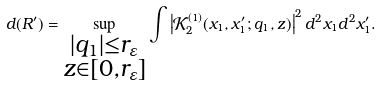Convert formula to latex. <formula><loc_0><loc_0><loc_500><loc_500>d ( R ^ { \prime } ) = \sup _ { \substack { | q _ { 1 } | \leq r _ { \varepsilon } \\ z \in [ 0 , r _ { \varepsilon } ] } } \int \left | \mathcal { K } _ { 2 } ^ { ( 1 ) } ( x _ { 1 } , x _ { 1 } ^ { \prime } ; q _ { 1 } , z ) \right | ^ { 2 } d ^ { 2 } x _ { 1 } d ^ { 2 } x _ { 1 } ^ { \prime } .</formula> 